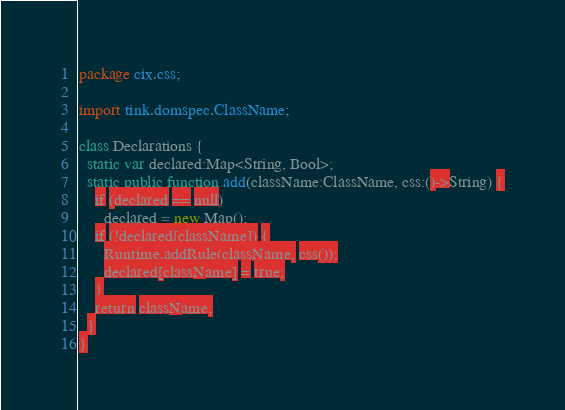Convert code to text. <code><loc_0><loc_0><loc_500><loc_500><_Haxe_>package cix.css;

import tink.domspec.ClassName;

class Declarations {
  static var declared:Map<String, Bool>;
  static public function add(className:ClassName, css:()->String) {
    if (declared == null)
      declared = new Map();
    if (!declared[className]) {
      Runtime.addRule(className, css());
      declared[className] = true;
    }
    return className;
  }
}</code> 